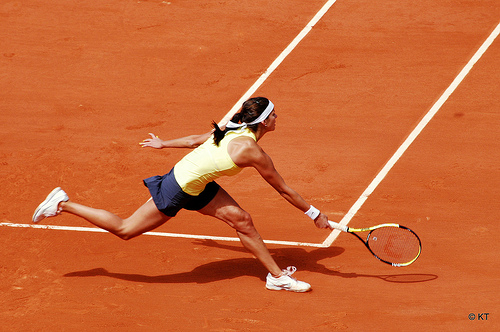Does the person to the left of the tennis racket wear a hat? No, the person to the left of the tennis racket is not wearing a hat; their hair is pulled back. 